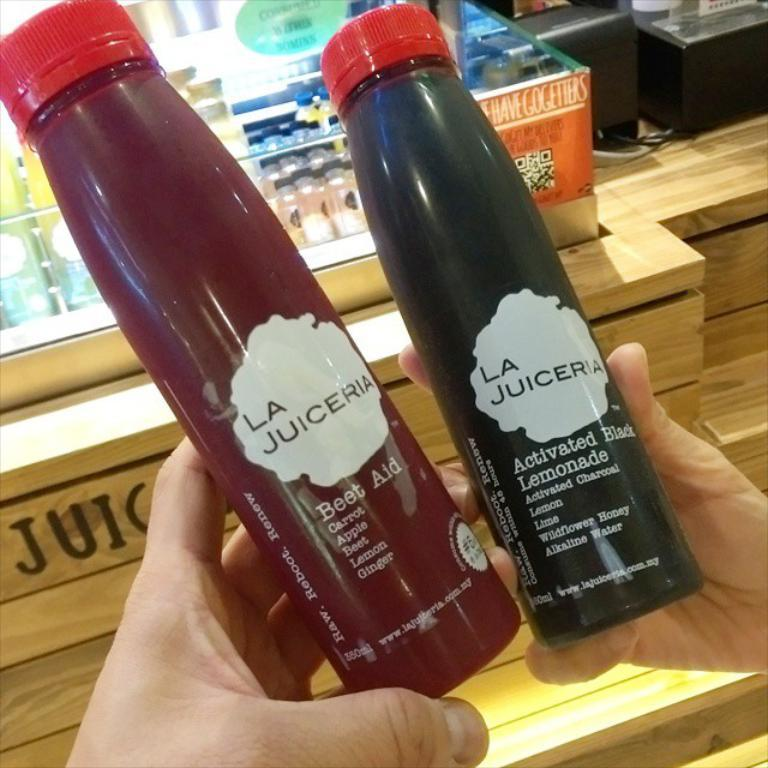What type of containers are visible in the image? There are two juice bottles with red caps in the image. Who is holding the bottles in the image? The bottles are being held by a person. What can be seen in the background of the image? There is a group of bottles placed in the background of the image. What type of tail can be seen on the cat in the image? There is no cat present in the image, so there is no tail to be seen. 